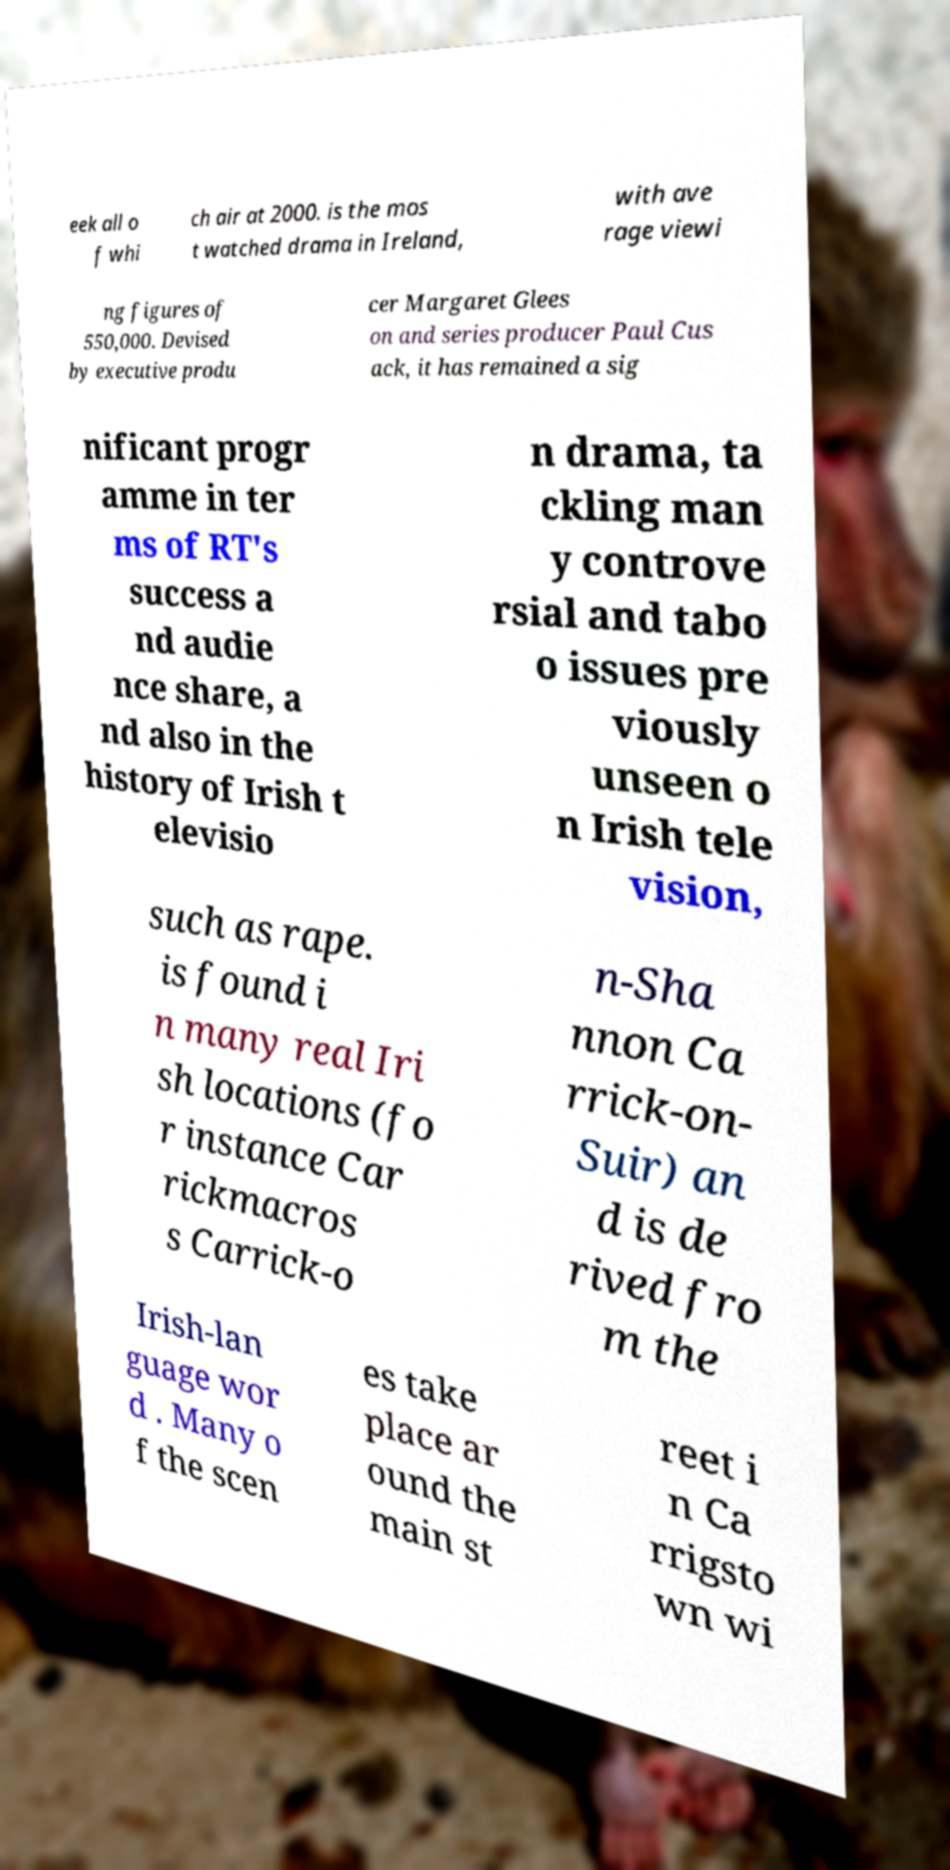Could you assist in decoding the text presented in this image and type it out clearly? eek all o f whi ch air at 2000. is the mos t watched drama in Ireland, with ave rage viewi ng figures of 550,000. Devised by executive produ cer Margaret Glees on and series producer Paul Cus ack, it has remained a sig nificant progr amme in ter ms of RT's success a nd audie nce share, a nd also in the history of Irish t elevisio n drama, ta ckling man y controve rsial and tabo o issues pre viously unseen o n Irish tele vision, such as rape. is found i n many real Iri sh locations (fo r instance Car rickmacros s Carrick-o n-Sha nnon Ca rrick-on- Suir) an d is de rived fro m the Irish-lan guage wor d . Many o f the scen es take place ar ound the main st reet i n Ca rrigsto wn wi 